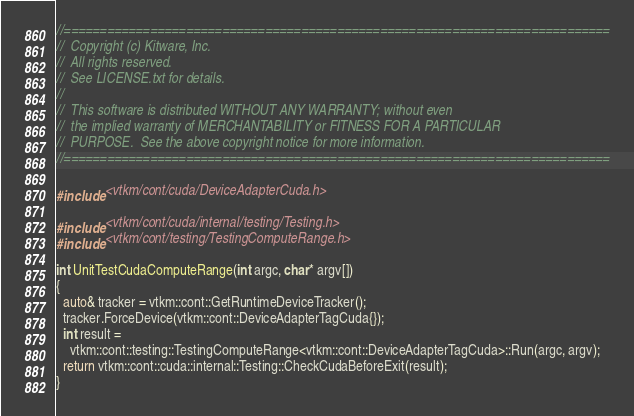Convert code to text. <code><loc_0><loc_0><loc_500><loc_500><_Cuda_>//============================================================================
//  Copyright (c) Kitware, Inc.
//  All rights reserved.
//  See LICENSE.txt for details.
//
//  This software is distributed WITHOUT ANY WARRANTY; without even
//  the implied warranty of MERCHANTABILITY or FITNESS FOR A PARTICULAR
//  PURPOSE.  See the above copyright notice for more information.
//============================================================================

#include <vtkm/cont/cuda/DeviceAdapterCuda.h>

#include <vtkm/cont/cuda/internal/testing/Testing.h>
#include <vtkm/cont/testing/TestingComputeRange.h>

int UnitTestCudaComputeRange(int argc, char* argv[])
{
  auto& tracker = vtkm::cont::GetRuntimeDeviceTracker();
  tracker.ForceDevice(vtkm::cont::DeviceAdapterTagCuda{});
  int result =
    vtkm::cont::testing::TestingComputeRange<vtkm::cont::DeviceAdapterTagCuda>::Run(argc, argv);
  return vtkm::cont::cuda::internal::Testing::CheckCudaBeforeExit(result);
}
</code> 